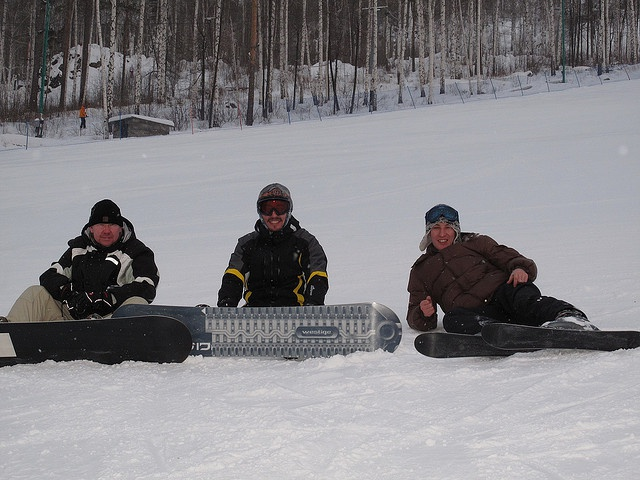Describe the objects in this image and their specific colors. I can see people in black, darkgray, gray, and maroon tones, snowboard in black, gray, and darkgray tones, people in black, gray, and darkgray tones, people in black, gray, maroon, and darkgray tones, and snowboard in black, darkgray, and gray tones in this image. 